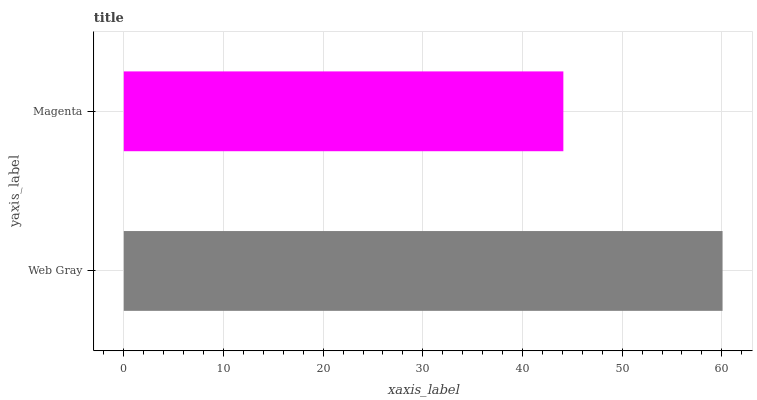Is Magenta the minimum?
Answer yes or no. Yes. Is Web Gray the maximum?
Answer yes or no. Yes. Is Magenta the maximum?
Answer yes or no. No. Is Web Gray greater than Magenta?
Answer yes or no. Yes. Is Magenta less than Web Gray?
Answer yes or no. Yes. Is Magenta greater than Web Gray?
Answer yes or no. No. Is Web Gray less than Magenta?
Answer yes or no. No. Is Web Gray the high median?
Answer yes or no. Yes. Is Magenta the low median?
Answer yes or no. Yes. Is Magenta the high median?
Answer yes or no. No. Is Web Gray the low median?
Answer yes or no. No. 